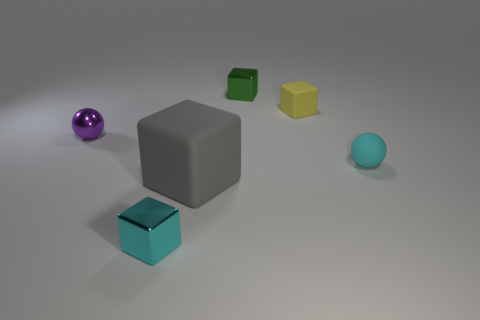Is there anything else that has the same size as the gray cube?
Provide a succinct answer. No. Do the cyan rubber object and the small matte object that is left of the small cyan matte object have the same shape?
Keep it short and to the point. No. There is a small sphere that is on the left side of the tiny shiny thing that is in front of the gray rubber object; what is it made of?
Ensure brevity in your answer.  Metal. Are there an equal number of small yellow objects in front of the yellow rubber object and small yellow shiny balls?
Your response must be concise. Yes. Are there any other things that are the same material as the yellow cube?
Your response must be concise. Yes. Does the small matte thing that is in front of the tiny rubber block have the same color as the metal cube that is behind the tiny yellow matte cube?
Your answer should be compact. No. What number of small objects are both to the left of the gray cube and behind the cyan cube?
Offer a very short reply. 1. How many other objects are the same shape as the small cyan metallic object?
Offer a very short reply. 3. Are there more large gray matte blocks on the right side of the large gray matte thing than gray rubber blocks?
Offer a very short reply. No. There is a small cube on the left side of the green shiny object; what is its color?
Ensure brevity in your answer.  Cyan. 